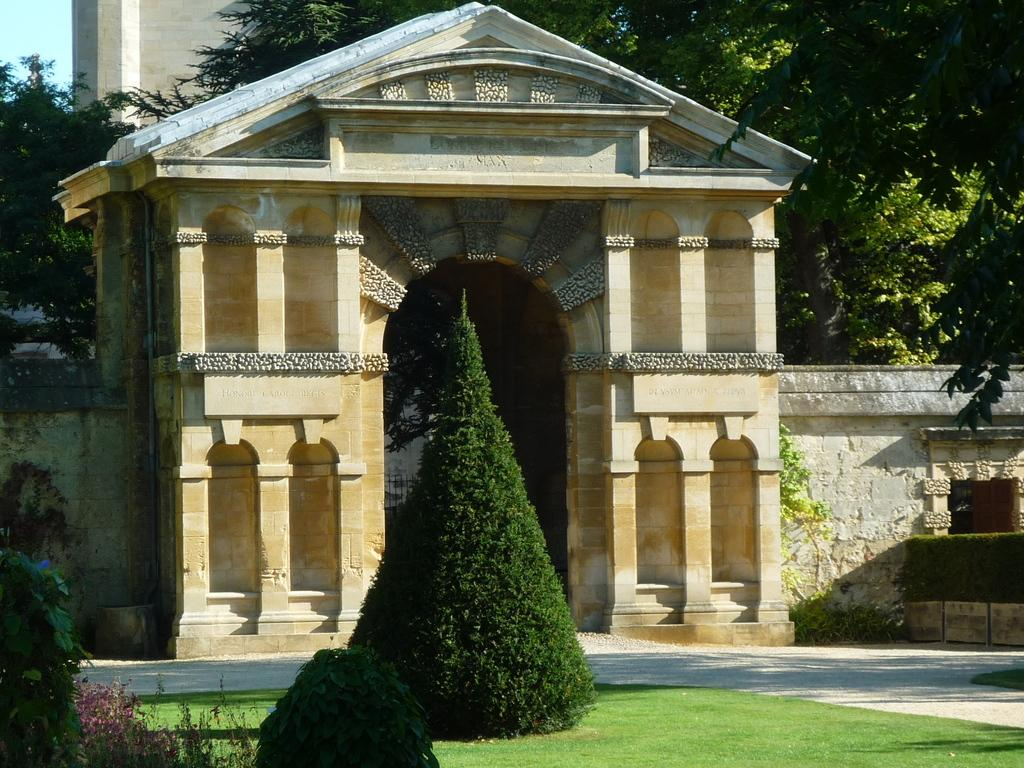What is the main feature of the image? There is an entrance in the image. What type of vegetation is present around the entrance? Trees are present around the entrance. What type of ground surface is visible in the image? Grass is visible in the image. How many arms are visible on the trees in the image? There are no arms visible on the trees in the image, as trees do not have arms. 